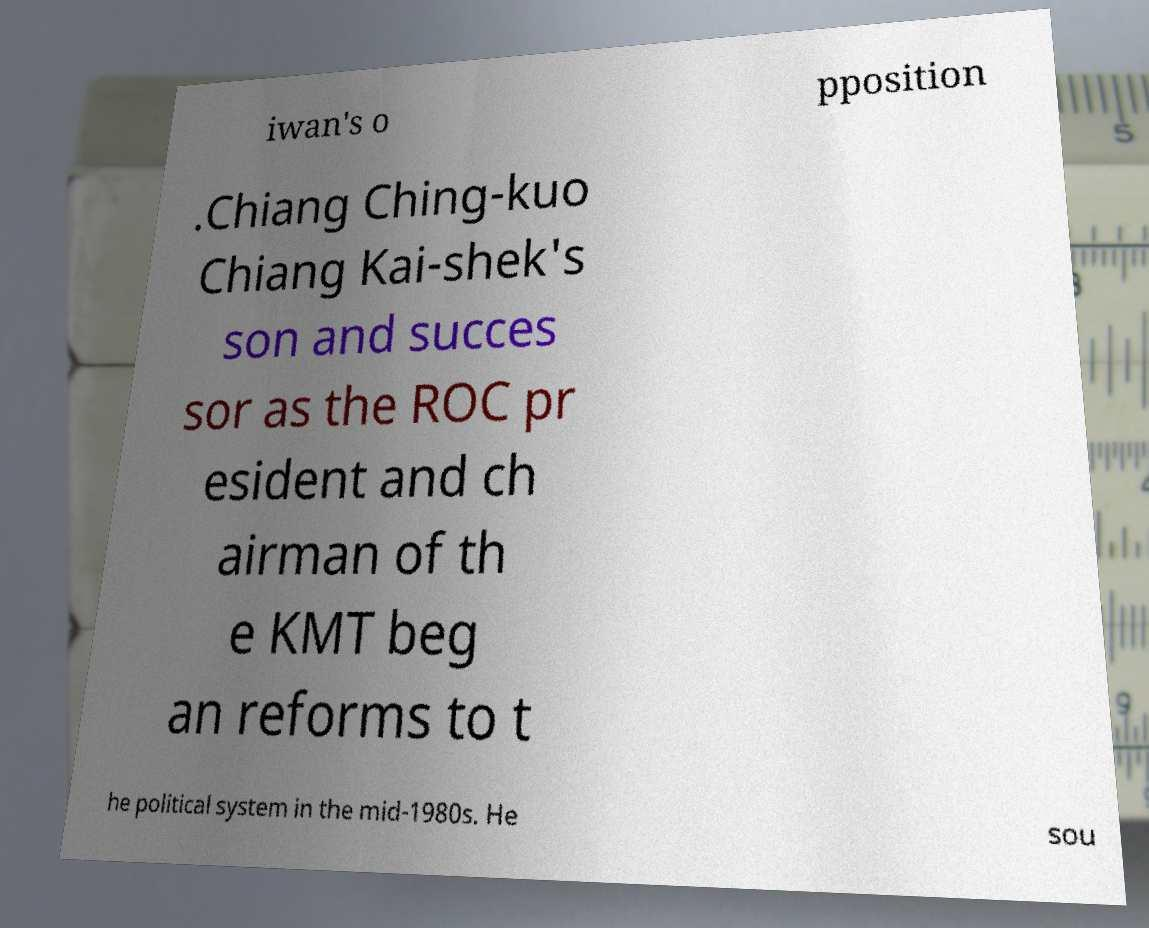I need the written content from this picture converted into text. Can you do that? iwan's o pposition .Chiang Ching-kuo Chiang Kai-shek's son and succes sor as the ROC pr esident and ch airman of th e KMT beg an reforms to t he political system in the mid-1980s. He sou 